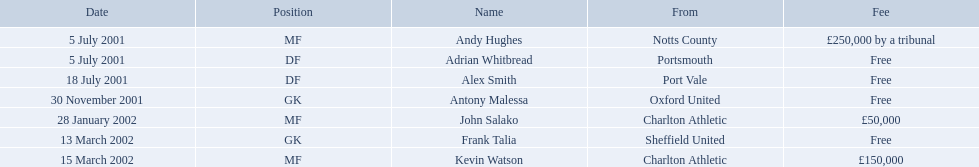Would you mind parsing the complete table? {'header': ['Date', 'Position', 'Name', 'From', 'Fee'], 'rows': [['5 July 2001', 'MF', 'Andy Hughes', 'Notts County', '£250,000 by a tribunal'], ['5 July 2001', 'DF', 'Adrian Whitbread', 'Portsmouth', 'Free'], ['18 July 2001', 'DF', 'Alex Smith', 'Port Vale', 'Free'], ['30 November 2001', 'GK', 'Antony Malessa', 'Oxford United', 'Free'], ['28 January 2002', 'MF', 'John Salako', 'Charlton Athletic', '£50,000'], ['13 March 2002', 'GK', 'Frank Talia', 'Sheffield United', 'Free'], ['15 March 2002', 'MF', 'Kevin Watson', 'Charlton Athletic', '£150,000']]} Which players in the 2001-02 reading f.c. season played the mf position? Andy Hughes, John Salako, Kevin Watson. Of these players, which ones transferred in 2002? John Salako, Kevin Watson. Of these players, who had the highest transfer fee? Kevin Watson. What was this player's transfer fee? £150,000. List all the players names Andy Hughes, Adrian Whitbread, Alex Smith, Antony Malessa, John Salako, Frank Talia, Kevin Watson. Of these who is kevin watson Kevin Watson. To what transfer fee entry does kevin correspond to? £150,000. What are the appellations of all the participants? Andy Hughes, Adrian Whitbread, Alex Smith, Antony Malessa, John Salako, Frank Talia, Kevin Watson. What charge did andy hughes demand? £250,000 by a tribunal. What charge did john salako demand? £50,000. Which participant had the greatest charge, andy hughes or john salako? Andy Hughes. Which individuals in the 2001-02 reading f.c. season played the midfield position? Andy Hughes, John Salako, Kevin Watson. Of these individuals, which ones switched in 2002? John Salako, Kevin Watson. Of these individuals, who had the highest transfer amount? Kevin Watson. What was this individual's transfer amount? £150,000. What are the titles of every player? Andy Hughes, Adrian Whitbread, Alex Smith, Antony Malessa, John Salako, Frank Talia, Kevin Watson. What cost did andy hughes necessitate? £250,000 by a tribunal. What cost did john salako necessitate? £50,000. Which player had the supreme cost, andy hughes or john salako? Andy Hughes. What are the complete list of names? Andy Hughes, Adrian Whitbread, Alex Smith, Antony Malessa, John Salako, Frank Talia, Kevin Watson. What was the cost for every individual? £250,000 by a tribunal, Free, Free, Free, £50,000, Free, £150,000. And who had the greatest cost? Andy Hughes. What are the monikers of all the athletes? Andy Hughes, Adrian Whitbread, Alex Smith, Antony Malessa, John Salako, Frank Talia, Kevin Watson. What price did andy hughes require? £250,000 by a tribunal. What price did john salako require? £50,000. Which athlete had the topmost price, andy hughes or john salako? Andy Hughes. What are the names of all the people? Andy Hughes, Adrian Whitbread, Alex Smith, Antony Malessa, John Salako, Frank Talia, Kevin Watson. What was the amount each person had to pay? £250,000 by a tribunal, Free, Free, Free, £50,000, Free, £150,000. Who had the greatest fee? Andy Hughes. What are the names of each player? Andy Hughes, Adrian Whitbread, Alex Smith, Antony Malessa, John Salako, Frank Talia, Kevin Watson. How much was andy hughes' fee? £250,000 by a tribunal. I'm looking to parse the entire table for insights. Could you assist me with that? {'header': ['Date', 'Position', 'Name', 'From', 'Fee'], 'rows': [['5 July 2001', 'MF', 'Andy Hughes', 'Notts County', '£250,000 by a tribunal'], ['5 July 2001', 'DF', 'Adrian Whitbread', 'Portsmouth', 'Free'], ['18 July 2001', 'DF', 'Alex Smith', 'Port Vale', 'Free'], ['30 November 2001', 'GK', 'Antony Malessa', 'Oxford United', 'Free'], ['28 January 2002', 'MF', 'John Salako', 'Charlton Athletic', '£50,000'], ['13 March 2002', 'GK', 'Frank Talia', 'Sheffield United', 'Free'], ['15 March 2002', 'MF', 'Kevin Watson', 'Charlton Athletic', '£150,000']]} What was john salako's fee? £50,000. Which of the two players, andy hughes or john salako, had the higher fee? Andy Hughes. Who are all the participants? Andy Hughes, Adrian Whitbread, Alex Smith, Antony Malessa, John Salako, Frank Talia, Kevin Watson. What were the costs associated with each player? £250,000 by a tribunal, Free, Free, Free, £50,000, Free, £150,000. What was the amount of kevin watson's fee? £150,000. Can you list all the players? Andy Hughes, Adrian Whitbread, Alex Smith, Antony Malessa, John Salako, Frank Talia, Kevin Watson. What were the respective fees for each participant? £250,000 by a tribunal, Free, Free, Free, £50,000, Free, £150,000. What was the fee amount for kevin watson? £150,000. 